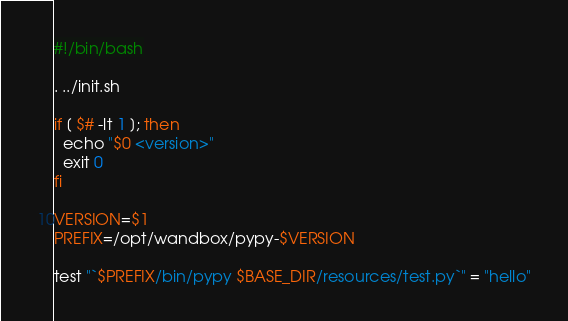Convert code to text. <code><loc_0><loc_0><loc_500><loc_500><_Bash_>#!/bin/bash

. ../init.sh

if [ $# -lt 1 ]; then
  echo "$0 <version>"
  exit 0
fi

VERSION=$1
PREFIX=/opt/wandbox/pypy-$VERSION

test "`$PREFIX/bin/pypy $BASE_DIR/resources/test.py`" = "hello"
</code> 